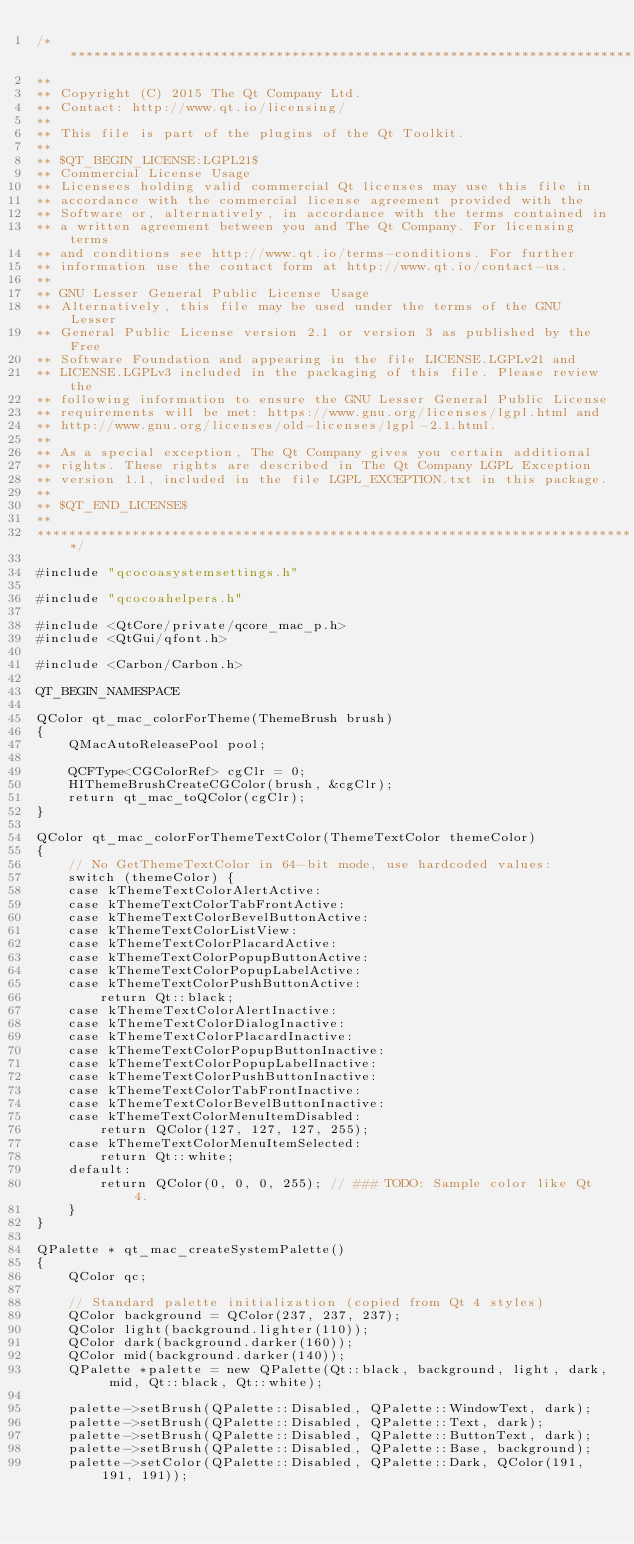Convert code to text. <code><loc_0><loc_0><loc_500><loc_500><_ObjectiveC_>/****************************************************************************
**
** Copyright (C) 2015 The Qt Company Ltd.
** Contact: http://www.qt.io/licensing/
**
** This file is part of the plugins of the Qt Toolkit.
**
** $QT_BEGIN_LICENSE:LGPL21$
** Commercial License Usage
** Licensees holding valid commercial Qt licenses may use this file in
** accordance with the commercial license agreement provided with the
** Software or, alternatively, in accordance with the terms contained in
** a written agreement between you and The Qt Company. For licensing terms
** and conditions see http://www.qt.io/terms-conditions. For further
** information use the contact form at http://www.qt.io/contact-us.
**
** GNU Lesser General Public License Usage
** Alternatively, this file may be used under the terms of the GNU Lesser
** General Public License version 2.1 or version 3 as published by the Free
** Software Foundation and appearing in the file LICENSE.LGPLv21 and
** LICENSE.LGPLv3 included in the packaging of this file. Please review the
** following information to ensure the GNU Lesser General Public License
** requirements will be met: https://www.gnu.org/licenses/lgpl.html and
** http://www.gnu.org/licenses/old-licenses/lgpl-2.1.html.
**
** As a special exception, The Qt Company gives you certain additional
** rights. These rights are described in The Qt Company LGPL Exception
** version 1.1, included in the file LGPL_EXCEPTION.txt in this package.
**
** $QT_END_LICENSE$
**
****************************************************************************/

#include "qcocoasystemsettings.h"

#include "qcocoahelpers.h"

#include <QtCore/private/qcore_mac_p.h>
#include <QtGui/qfont.h>

#include <Carbon/Carbon.h>

QT_BEGIN_NAMESPACE

QColor qt_mac_colorForTheme(ThemeBrush brush)
{
    QMacAutoReleasePool pool;

    QCFType<CGColorRef> cgClr = 0;
    HIThemeBrushCreateCGColor(brush, &cgClr);
    return qt_mac_toQColor(cgClr);
}

QColor qt_mac_colorForThemeTextColor(ThemeTextColor themeColor)
{
    // No GetThemeTextColor in 64-bit mode, use hardcoded values:
    switch (themeColor) {
    case kThemeTextColorAlertActive:
    case kThemeTextColorTabFrontActive:
    case kThemeTextColorBevelButtonActive:
    case kThemeTextColorListView:
    case kThemeTextColorPlacardActive:
    case kThemeTextColorPopupButtonActive:
    case kThemeTextColorPopupLabelActive:
    case kThemeTextColorPushButtonActive:
        return Qt::black;
    case kThemeTextColorAlertInactive:
    case kThemeTextColorDialogInactive:
    case kThemeTextColorPlacardInactive:
    case kThemeTextColorPopupButtonInactive:
    case kThemeTextColorPopupLabelInactive:
    case kThemeTextColorPushButtonInactive:
    case kThemeTextColorTabFrontInactive:
    case kThemeTextColorBevelButtonInactive:
    case kThemeTextColorMenuItemDisabled:
        return QColor(127, 127, 127, 255);
    case kThemeTextColorMenuItemSelected:
        return Qt::white;
    default:
        return QColor(0, 0, 0, 255); // ### TODO: Sample color like Qt 4.
    }
}

QPalette * qt_mac_createSystemPalette()
{
    QColor qc;

    // Standard palette initialization (copied from Qt 4 styles)
    QColor background = QColor(237, 237, 237);
    QColor light(background.lighter(110));
    QColor dark(background.darker(160));
    QColor mid(background.darker(140));
    QPalette *palette = new QPalette(Qt::black, background, light, dark, mid, Qt::black, Qt::white);

    palette->setBrush(QPalette::Disabled, QPalette::WindowText, dark);
    palette->setBrush(QPalette::Disabled, QPalette::Text, dark);
    palette->setBrush(QPalette::Disabled, QPalette::ButtonText, dark);
    palette->setBrush(QPalette::Disabled, QPalette::Base, background);
    palette->setColor(QPalette::Disabled, QPalette::Dark, QColor(191, 191, 191));</code> 